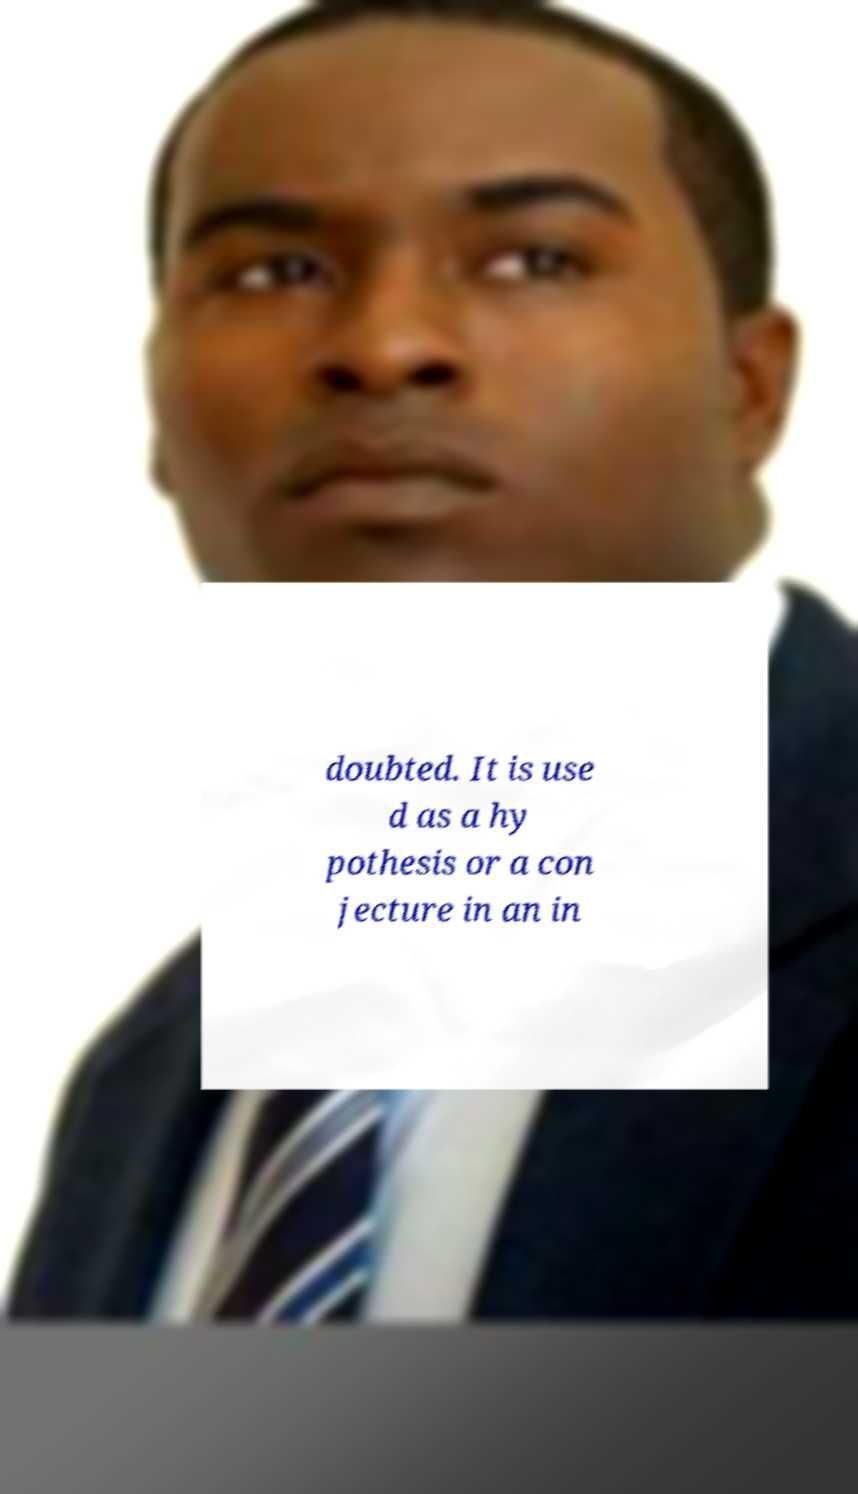Please read and relay the text visible in this image. What does it say? doubted. It is use d as a hy pothesis or a con jecture in an in 